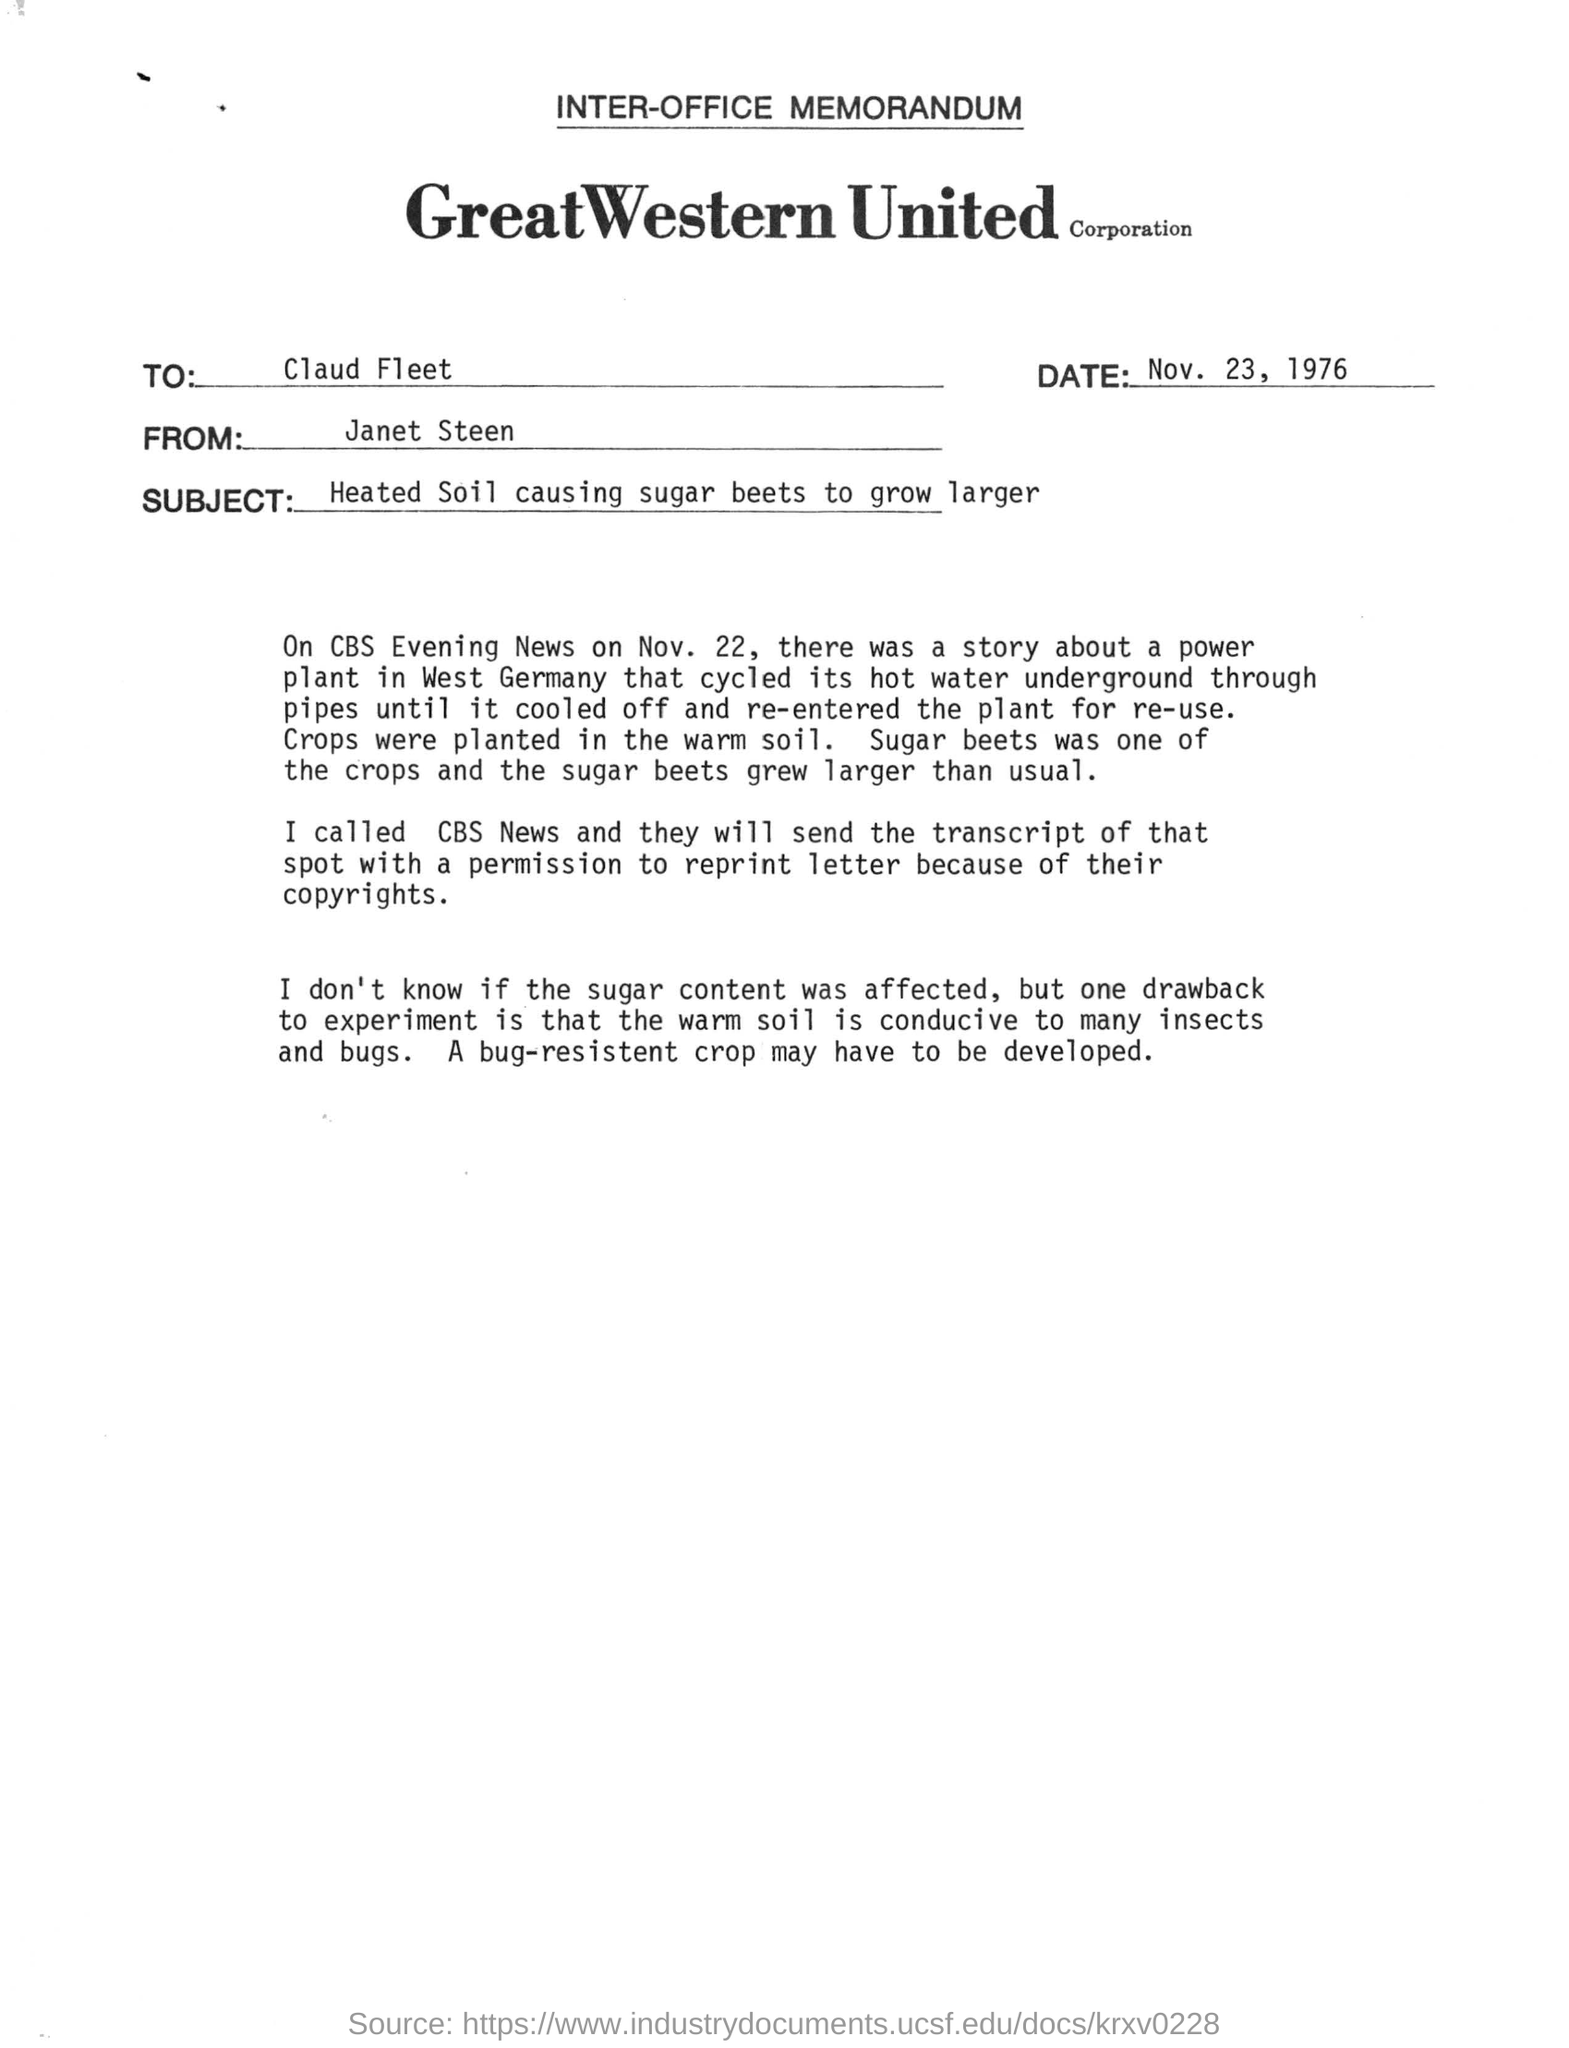Indicate a few pertinent items in this graphic. What is the name of the company? It is GREATWESTERN UNITED CORPORATION. The document in question is about the subject of heated soil causing sugar beets to grow larger. To whom this letter is addressed: Claud Fleet. 